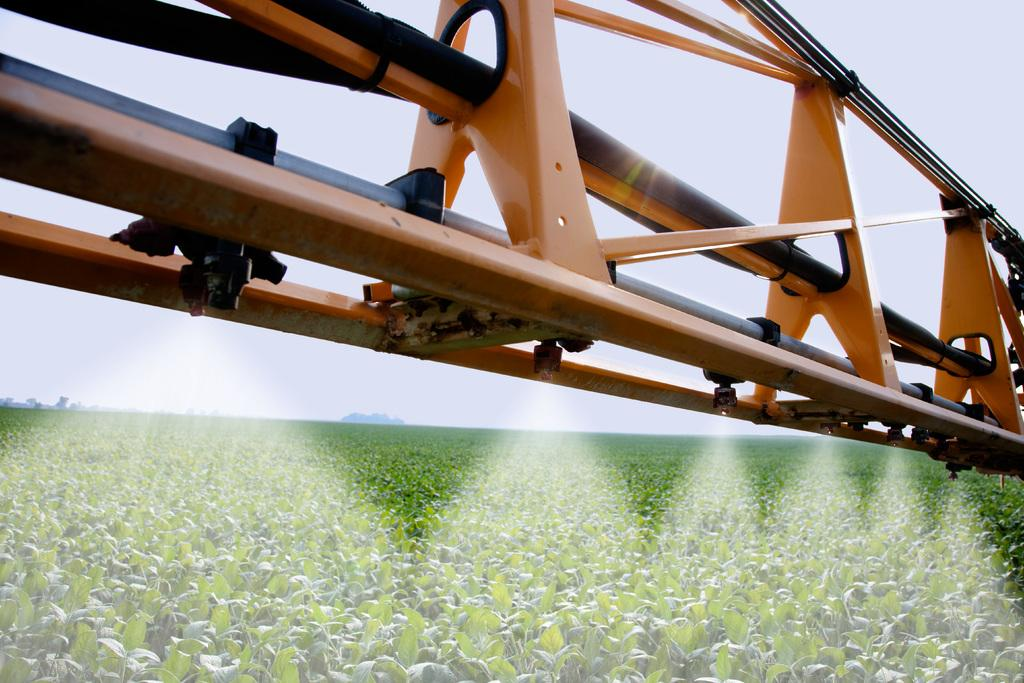What type of landscape is visible at the bottom of the image? There is a field at the bottom of the image. What can be seen at the top of the image? There is a metal object present at the top of the image. What is visible in the background of the image? The sky is visible in the background of the image. How many jellyfish can be seen swimming in the field at the bottom of the image? There are no jellyfish present in the image; it features a field and a metal object. What type of animal is interacting with the metal object at the top of the image? There is no animal present in the image; it only features a metal object and a field. 